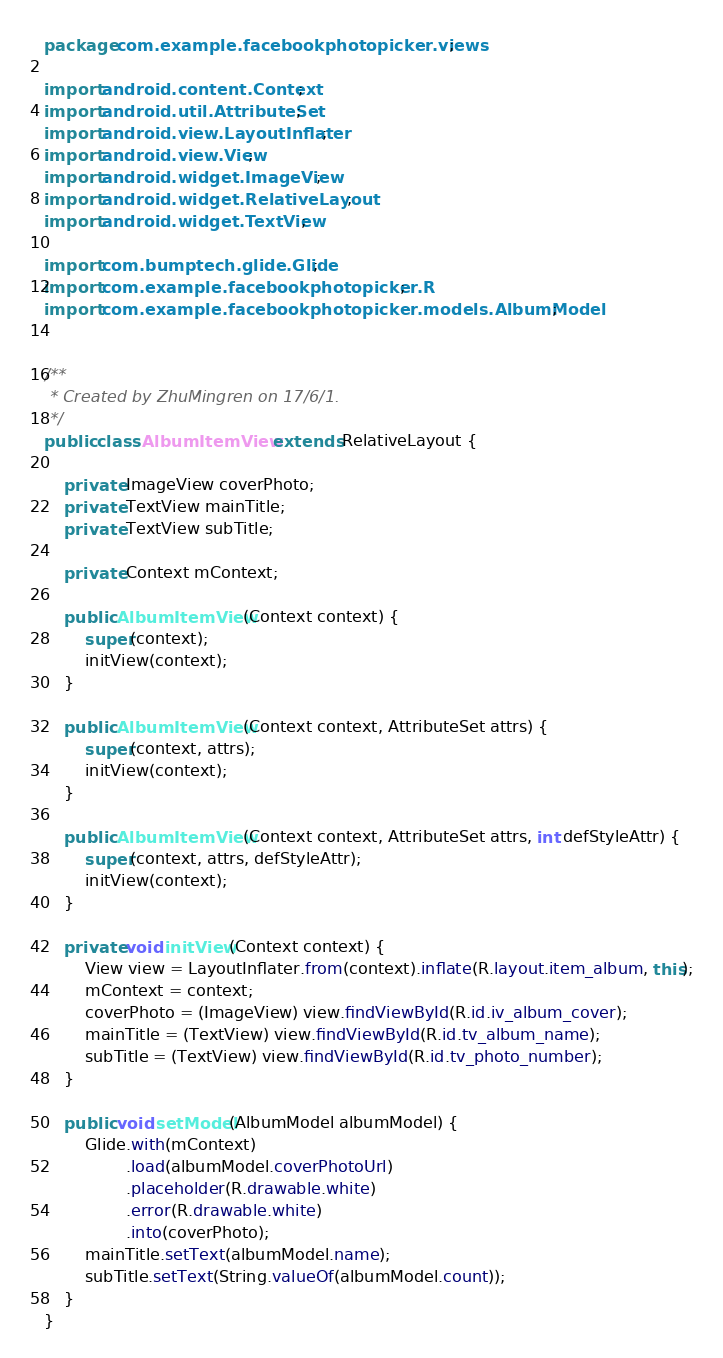Convert code to text. <code><loc_0><loc_0><loc_500><loc_500><_Java_>package com.example.facebookphotopicker.views;

import android.content.Context;
import android.util.AttributeSet;
import android.view.LayoutInflater;
import android.view.View;
import android.widget.ImageView;
import android.widget.RelativeLayout;
import android.widget.TextView;

import com.bumptech.glide.Glide;
import com.example.facebookphotopicker.R;
import com.example.facebookphotopicker.models.AlbumModel;


/**
 * Created by ZhuMingren on 17/6/1.
 */
public class AlbumItemView extends RelativeLayout {

    private ImageView coverPhoto;
    private TextView mainTitle;
    private TextView subTitle;

    private Context mContext;

    public AlbumItemView(Context context) {
        super(context);
        initView(context);
    }

    public AlbumItemView(Context context, AttributeSet attrs) {
        super(context, attrs);
        initView(context);
    }

    public AlbumItemView(Context context, AttributeSet attrs, int defStyleAttr) {
        super(context, attrs, defStyleAttr);
        initView(context);
    }

    private void initView(Context context) {
        View view = LayoutInflater.from(context).inflate(R.layout.item_album, this);
        mContext = context;
        coverPhoto = (ImageView) view.findViewById(R.id.iv_album_cover);
        mainTitle = (TextView) view.findViewById(R.id.tv_album_name);
        subTitle = (TextView) view.findViewById(R.id.tv_photo_number);
    }

    public void setModel(AlbumModel albumModel) {
        Glide.with(mContext)
                .load(albumModel.coverPhotoUrl)
                .placeholder(R.drawable.white)
                .error(R.drawable.white)
                .into(coverPhoto);
        mainTitle.setText(albumModel.name);
        subTitle.setText(String.valueOf(albumModel.count));
    }
}
</code> 